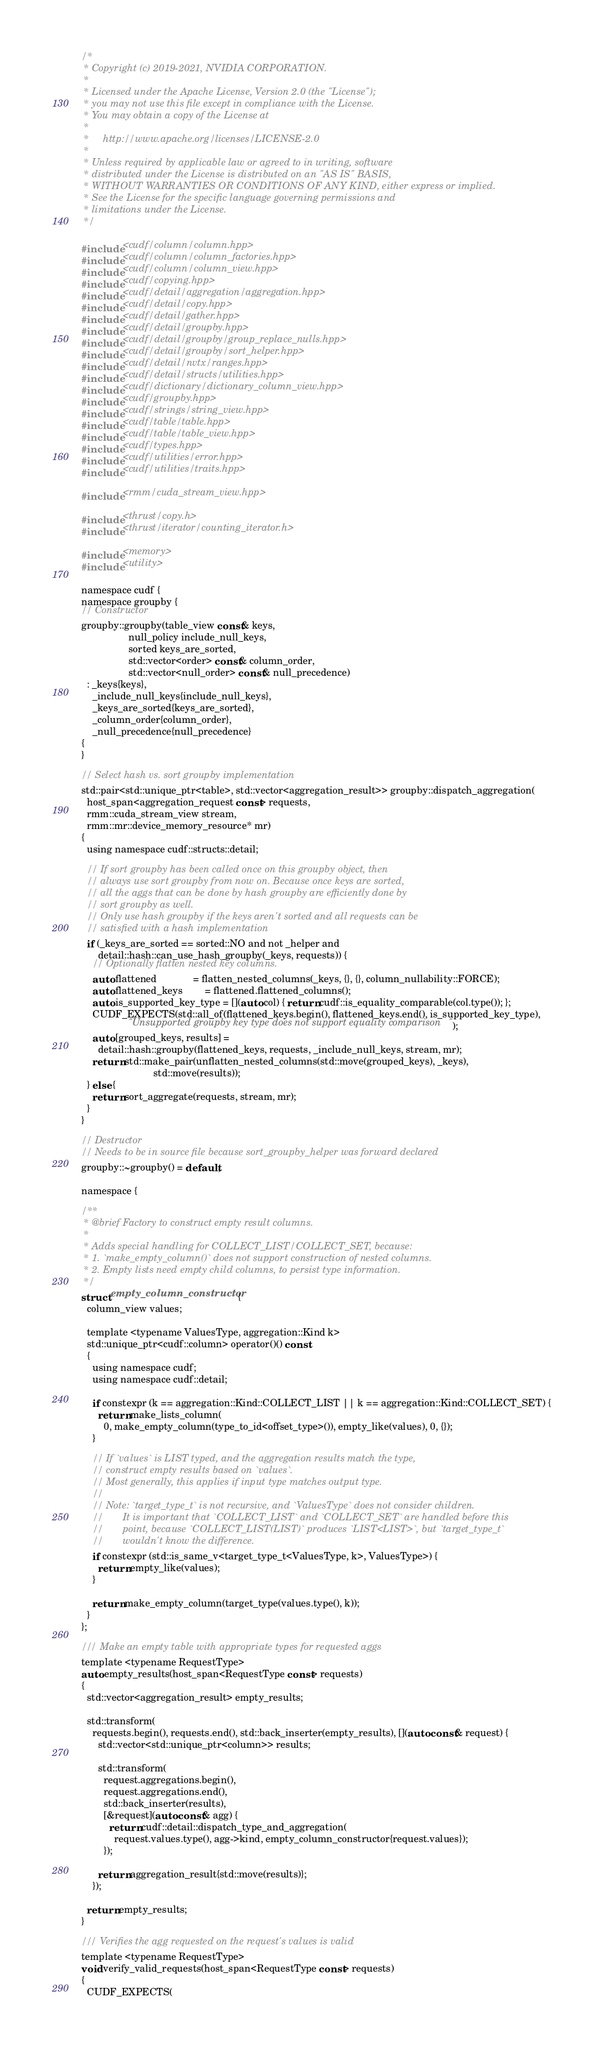Convert code to text. <code><loc_0><loc_0><loc_500><loc_500><_Cuda_>/*
 * Copyright (c) 2019-2021, NVIDIA CORPORATION.
 *
 * Licensed under the Apache License, Version 2.0 (the "License");
 * you may not use this file except in compliance with the License.
 * You may obtain a copy of the License at
 *
 *     http://www.apache.org/licenses/LICENSE-2.0
 *
 * Unless required by applicable law or agreed to in writing, software
 * distributed under the License is distributed on an "AS IS" BASIS,
 * WITHOUT WARRANTIES OR CONDITIONS OF ANY KIND, either express or implied.
 * See the License for the specific language governing permissions and
 * limitations under the License.
 */

#include <cudf/column/column.hpp>
#include <cudf/column/column_factories.hpp>
#include <cudf/column/column_view.hpp>
#include <cudf/copying.hpp>
#include <cudf/detail/aggregation/aggregation.hpp>
#include <cudf/detail/copy.hpp>
#include <cudf/detail/gather.hpp>
#include <cudf/detail/groupby.hpp>
#include <cudf/detail/groupby/group_replace_nulls.hpp>
#include <cudf/detail/groupby/sort_helper.hpp>
#include <cudf/detail/nvtx/ranges.hpp>
#include <cudf/detail/structs/utilities.hpp>
#include <cudf/dictionary/dictionary_column_view.hpp>
#include <cudf/groupby.hpp>
#include <cudf/strings/string_view.hpp>
#include <cudf/table/table.hpp>
#include <cudf/table/table_view.hpp>
#include <cudf/types.hpp>
#include <cudf/utilities/error.hpp>
#include <cudf/utilities/traits.hpp>

#include <rmm/cuda_stream_view.hpp>

#include <thrust/copy.h>
#include <thrust/iterator/counting_iterator.h>

#include <memory>
#include <utility>

namespace cudf {
namespace groupby {
// Constructor
groupby::groupby(table_view const& keys,
                 null_policy include_null_keys,
                 sorted keys_are_sorted,
                 std::vector<order> const& column_order,
                 std::vector<null_order> const& null_precedence)
  : _keys{keys},
    _include_null_keys{include_null_keys},
    _keys_are_sorted{keys_are_sorted},
    _column_order{column_order},
    _null_precedence{null_precedence}
{
}

// Select hash vs. sort groupby implementation
std::pair<std::unique_ptr<table>, std::vector<aggregation_result>> groupby::dispatch_aggregation(
  host_span<aggregation_request const> requests,
  rmm::cuda_stream_view stream,
  rmm::mr::device_memory_resource* mr)
{
  using namespace cudf::structs::detail;

  // If sort groupby has been called once on this groupby object, then
  // always use sort groupby from now on. Because once keys are sorted,
  // all the aggs that can be done by hash groupby are efficiently done by
  // sort groupby as well.
  // Only use hash groupby if the keys aren't sorted and all requests can be
  // satisfied with a hash implementation
  if (_keys_are_sorted == sorted::NO and not _helper and
      detail::hash::can_use_hash_groupby(_keys, requests)) {
    // Optionally flatten nested key columns.
    auto flattened             = flatten_nested_columns(_keys, {}, {}, column_nullability::FORCE);
    auto flattened_keys        = flattened.flattened_columns();
    auto is_supported_key_type = [](auto col) { return cudf::is_equality_comparable(col.type()); };
    CUDF_EXPECTS(std::all_of(flattened_keys.begin(), flattened_keys.end(), is_supported_key_type),
                 "Unsupported groupby key type does not support equality comparison");
    auto [grouped_keys, results] =
      detail::hash::groupby(flattened_keys, requests, _include_null_keys, stream, mr);
    return std::make_pair(unflatten_nested_columns(std::move(grouped_keys), _keys),
                          std::move(results));
  } else {
    return sort_aggregate(requests, stream, mr);
  }
}

// Destructor
// Needs to be in source file because sort_groupby_helper was forward declared
groupby::~groupby() = default;

namespace {

/**
 * @brief Factory to construct empty result columns.
 *
 * Adds special handling for COLLECT_LIST/COLLECT_SET, because:
 * 1. `make_empty_column()` does not support construction of nested columns.
 * 2. Empty lists need empty child columns, to persist type information.
 */
struct empty_column_constructor {
  column_view values;

  template <typename ValuesType, aggregation::Kind k>
  std::unique_ptr<cudf::column> operator()() const
  {
    using namespace cudf;
    using namespace cudf::detail;

    if constexpr (k == aggregation::Kind::COLLECT_LIST || k == aggregation::Kind::COLLECT_SET) {
      return make_lists_column(
        0, make_empty_column(type_to_id<offset_type>()), empty_like(values), 0, {});
    }

    // If `values` is LIST typed, and the aggregation results match the type,
    // construct empty results based on `values`.
    // Most generally, this applies if input type matches output type.
    //
    // Note: `target_type_t` is not recursive, and `ValuesType` does not consider children.
    //       It is important that `COLLECT_LIST` and `COLLECT_SET` are handled before this
    //       point, because `COLLECT_LIST(LIST)` produces `LIST<LIST>`, but `target_type_t`
    //       wouldn't know the difference.
    if constexpr (std::is_same_v<target_type_t<ValuesType, k>, ValuesType>) {
      return empty_like(values);
    }

    return make_empty_column(target_type(values.type(), k));
  }
};

/// Make an empty table with appropriate types for requested aggs
template <typename RequestType>
auto empty_results(host_span<RequestType const> requests)
{
  std::vector<aggregation_result> empty_results;

  std::transform(
    requests.begin(), requests.end(), std::back_inserter(empty_results), [](auto const& request) {
      std::vector<std::unique_ptr<column>> results;

      std::transform(
        request.aggregations.begin(),
        request.aggregations.end(),
        std::back_inserter(results),
        [&request](auto const& agg) {
          return cudf::detail::dispatch_type_and_aggregation(
            request.values.type(), agg->kind, empty_column_constructor{request.values});
        });

      return aggregation_result{std::move(results)};
    });

  return empty_results;
}

/// Verifies the agg requested on the request's values is valid
template <typename RequestType>
void verify_valid_requests(host_span<RequestType const> requests)
{
  CUDF_EXPECTS(</code> 